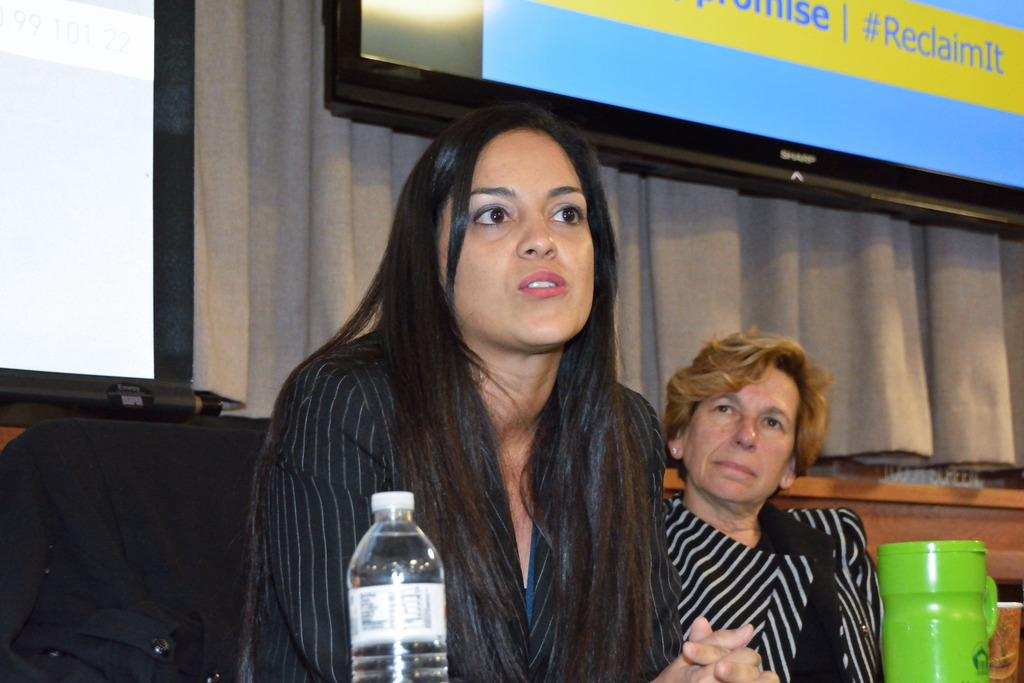How many people are present in the image? There are two persons sitting in the center of the image. What is placed in front of the sitting persons? There is a water bottle in front of the sitting persons. What can be seen in the background of the image? There is a wall in the background of the image. Is there any window treatment visible in the image? Yes, there is a curtain associated with the wall in the background. What type of scarf is the bear wearing in the image? There are no bears present in the image, and therefore no scarf can be observed on a bear. 